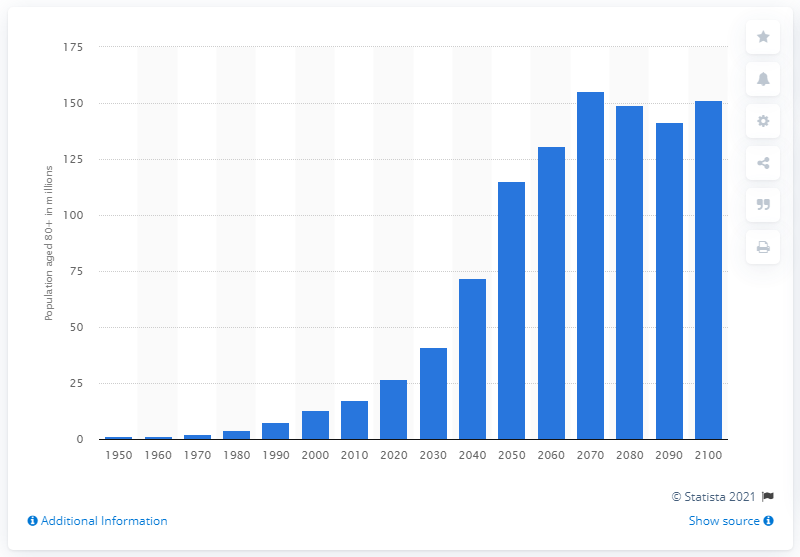Identify some key points in this picture. The forecast for China's 80-year-old population is for the year 2100. In 2010, there were approximately 17.29 million people aged 80 and above in China. 